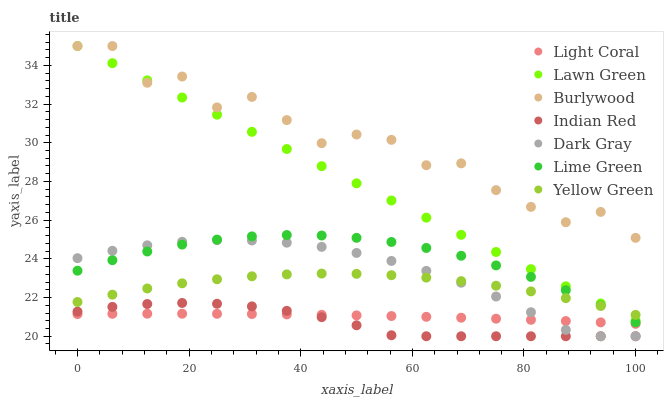Does Indian Red have the minimum area under the curve?
Answer yes or no. Yes. Does Burlywood have the maximum area under the curve?
Answer yes or no. Yes. Does Yellow Green have the minimum area under the curve?
Answer yes or no. No. Does Yellow Green have the maximum area under the curve?
Answer yes or no. No. Is Lawn Green the smoothest?
Answer yes or no. Yes. Is Burlywood the roughest?
Answer yes or no. Yes. Is Yellow Green the smoothest?
Answer yes or no. No. Is Yellow Green the roughest?
Answer yes or no. No. Does Dark Gray have the lowest value?
Answer yes or no. Yes. Does Yellow Green have the lowest value?
Answer yes or no. No. Does Burlywood have the highest value?
Answer yes or no. Yes. Does Yellow Green have the highest value?
Answer yes or no. No. Is Light Coral less than Yellow Green?
Answer yes or no. Yes. Is Burlywood greater than Light Coral?
Answer yes or no. Yes. Does Indian Red intersect Light Coral?
Answer yes or no. Yes. Is Indian Red less than Light Coral?
Answer yes or no. No. Is Indian Red greater than Light Coral?
Answer yes or no. No. Does Light Coral intersect Yellow Green?
Answer yes or no. No. 